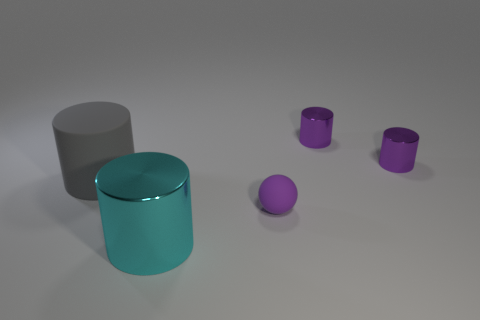Add 3 cyan things. How many objects exist? 8 Subtract all gray cylinders. How many cylinders are left? 3 Subtract all metal cylinders. How many cylinders are left? 1 Subtract all brown cylinders. Subtract all gray spheres. How many cylinders are left? 4 Subtract all spheres. How many objects are left? 4 Subtract all metal cylinders. Subtract all big rubber things. How many objects are left? 1 Add 1 small purple metallic objects. How many small purple metallic objects are left? 3 Add 2 shiny cylinders. How many shiny cylinders exist? 5 Subtract 0 blue cubes. How many objects are left? 5 